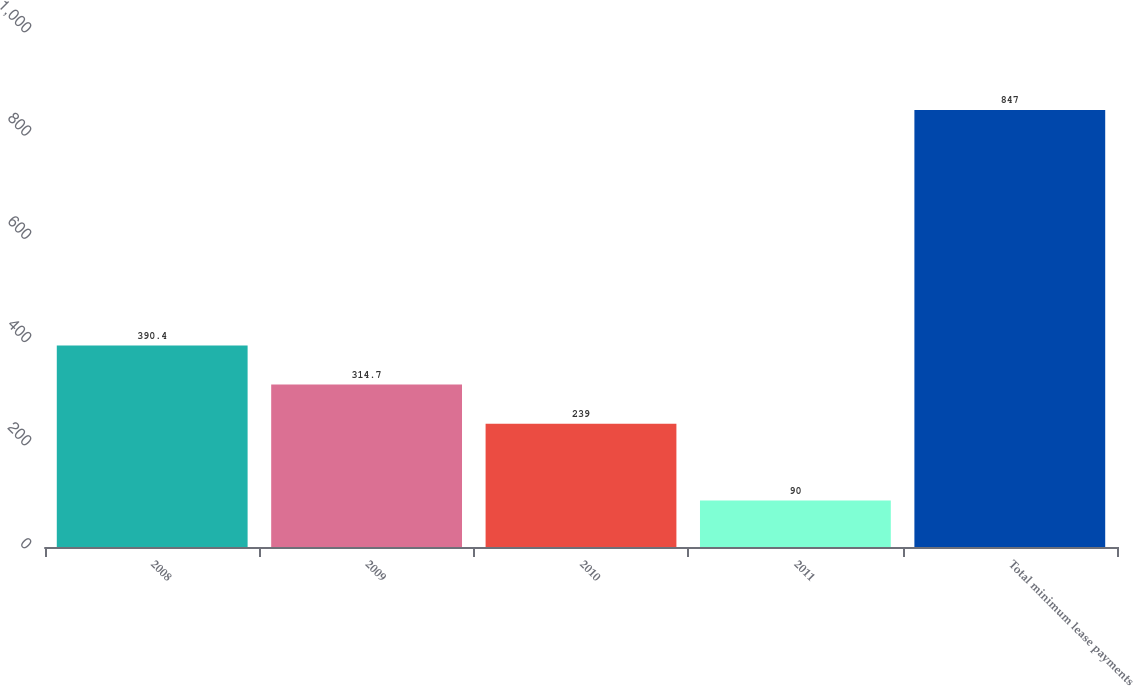Convert chart to OTSL. <chart><loc_0><loc_0><loc_500><loc_500><bar_chart><fcel>2008<fcel>2009<fcel>2010<fcel>2011<fcel>Total minimum lease payments<nl><fcel>390.4<fcel>314.7<fcel>239<fcel>90<fcel>847<nl></chart> 